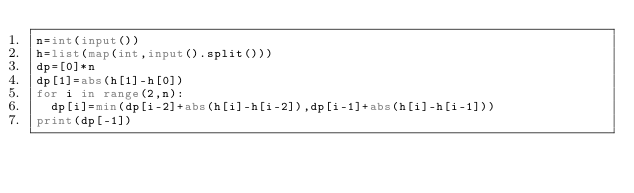Convert code to text. <code><loc_0><loc_0><loc_500><loc_500><_Python_>n=int(input())
h=list(map(int,input().split()))
dp=[0]*n
dp[1]=abs(h[1]-h[0])
for i in range(2,n):
  dp[i]=min(dp[i-2]+abs(h[i]-h[i-2]),dp[i-1]+abs(h[i]-h[i-1]))
print(dp[-1])</code> 